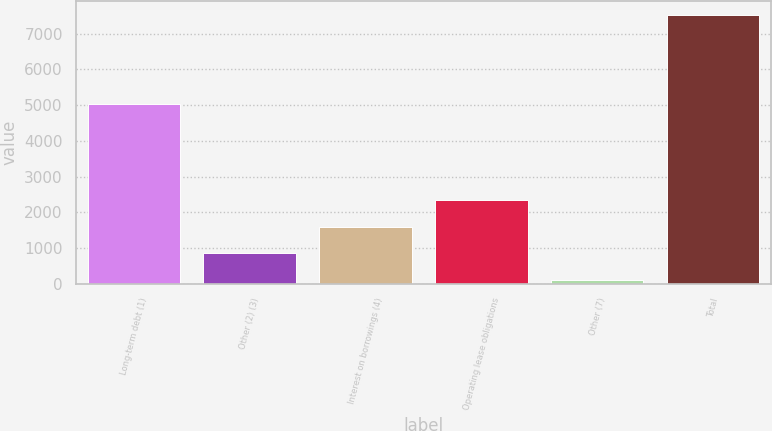<chart> <loc_0><loc_0><loc_500><loc_500><bar_chart><fcel>Long-term debt (1)<fcel>Other (2) (3)<fcel>Interest on borrowings (4)<fcel>Operating lease obligations<fcel>Other (7)<fcel>Total<nl><fcel>5024<fcel>848.9<fcel>1590.8<fcel>2332.7<fcel>107<fcel>7526<nl></chart> 